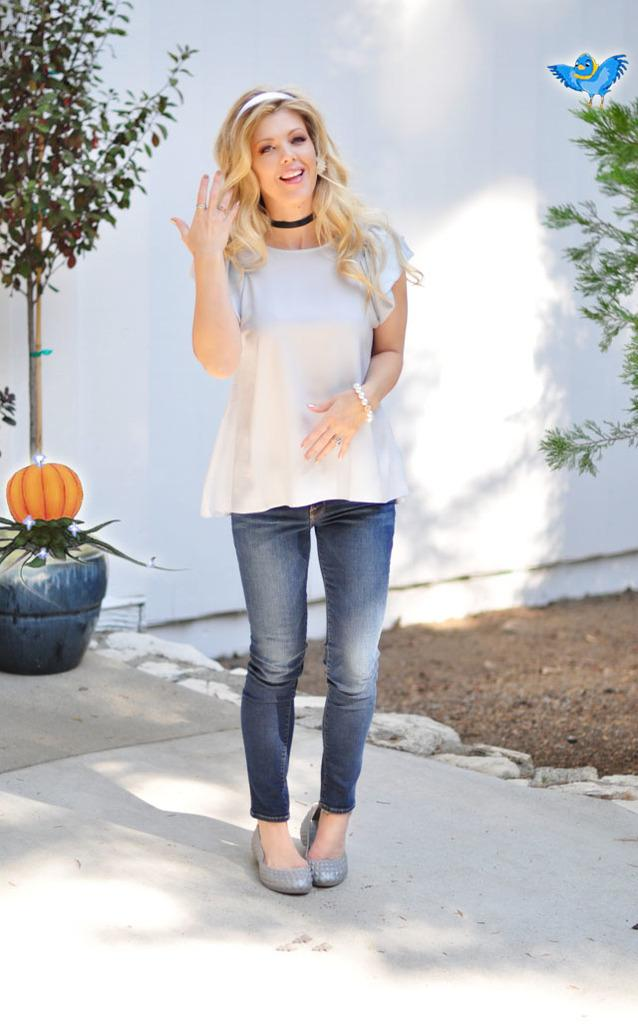Who is the main subject in the image? There is a lady in the center of the image. What can be seen in the background of the image? There is a wall in the background of the image. Are there any natural elements present in the image? Yes, there are plants in the image. What is the name of the faucet in the image? There is no faucet present in the image. Can you point out the lady's favorite color in the image? The provided facts do not mention the lady's favorite color, so it cannot be determined from the image. 